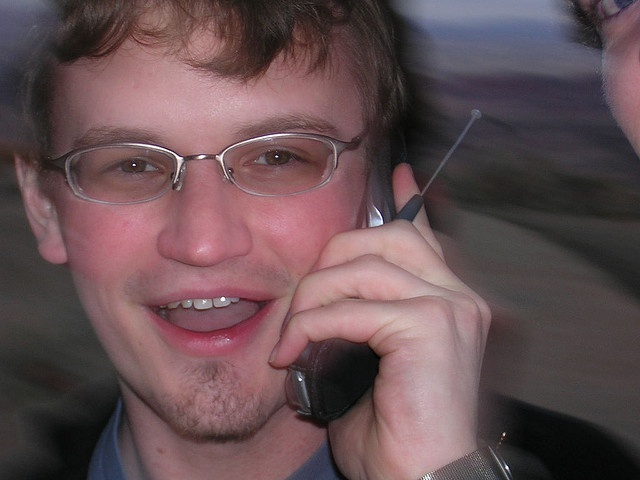Describe the objects in this image and their specific colors. I can see people in gray, brown, black, and darkgray tones, cell phone in gray and black tones, and people in gray, black, and purple tones in this image. 